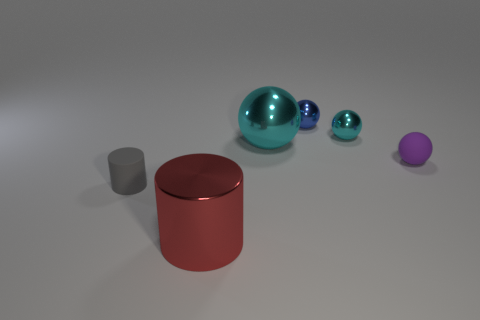What is the material of the object that is both right of the small gray rubber thing and in front of the rubber sphere?
Your response must be concise. Metal. There is a cyan ball left of the blue ball; what material is it?
Offer a terse response. Metal. What is the color of the large thing that is the same material as the big cyan sphere?
Provide a succinct answer. Red. There is a purple object; is its shape the same as the object on the left side of the red cylinder?
Offer a terse response. No. Are there any small metal spheres in front of the tiny purple thing?
Give a very brief answer. No. There is a small object that is the same color as the large shiny ball; what material is it?
Give a very brief answer. Metal. Do the purple matte ball and the cyan sphere that is to the right of the big metal ball have the same size?
Your response must be concise. Yes. Are there any small cubes of the same color as the big sphere?
Ensure brevity in your answer.  No. Are there any other objects that have the same shape as the tiny cyan shiny thing?
Provide a short and direct response. Yes. What shape is the tiny object that is both in front of the large cyan metal thing and on the right side of the gray cylinder?
Make the answer very short. Sphere. 